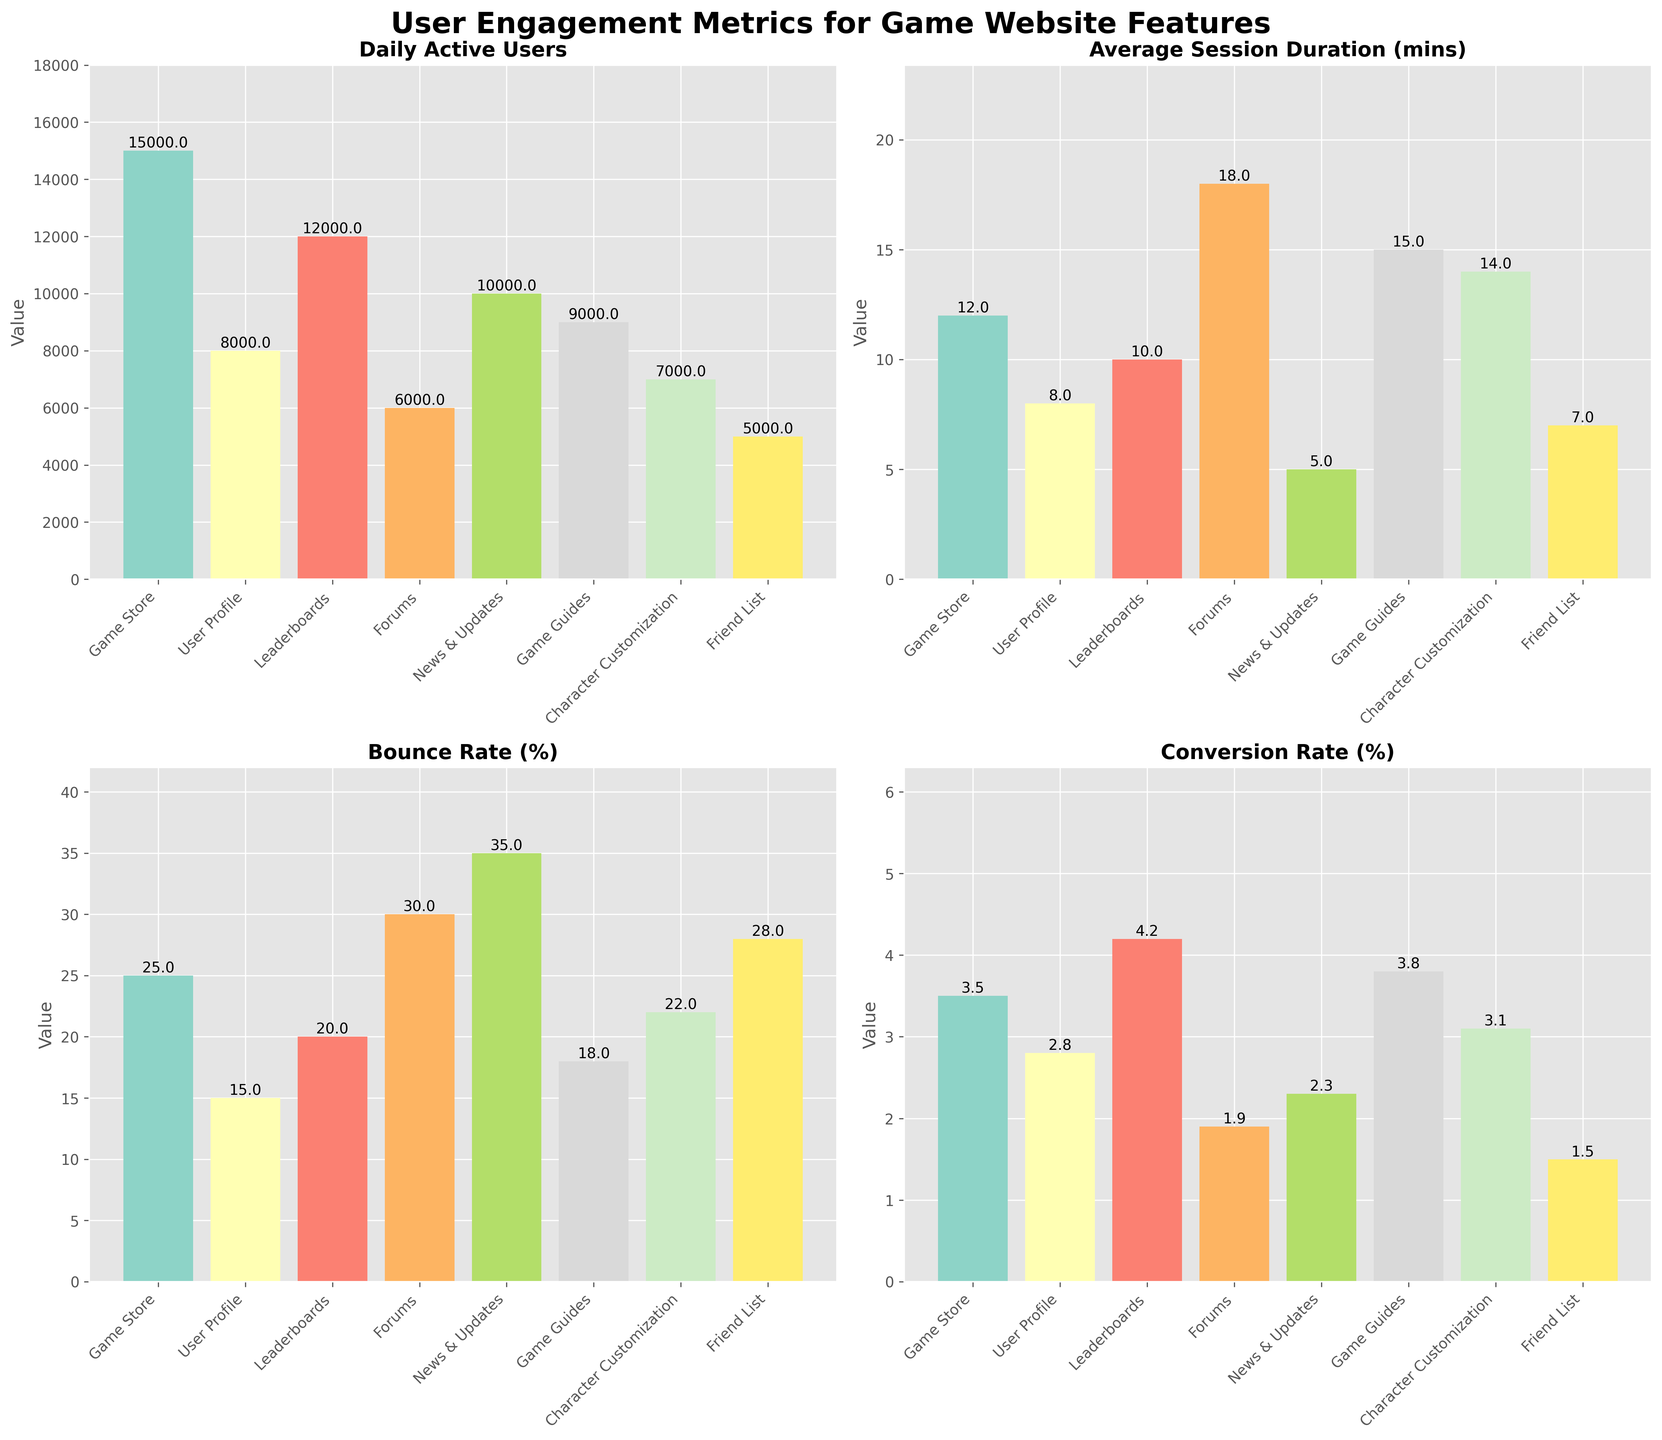what is the total number of daily active users for all features? Add up the Daily Active Users across all features: 15000 + 8000 + 12000 + 6000 + 10000 + 9000 + 7000 + 5000 = 82000
Answer: 82000 which feature has the highest average session duration? Look at the Average Session Duration (mins) subplot and identify the feature with the highest bar. Forums have a value of 18 mins.
Answer: Forums how does the bounce rate of news & updates compare to game store? Compare the heights of the Bounce Rate (%) bars for News & Updates and Game Store. News & Updates has 35% and Game Store has 25%.
Answer: News & Updates has a higher bounce rate what is the difference in conversion rate between leaderboards and friend list? Subtract the Conversion Rate (%) of Friend List from that of Leaderboards: 4.2 - 1.5 = 2.7
Answer: 2.7 which feature has the lowest bounce rate? Identify the shortest bar in the Bounce Rate (%) subplot. User Profile has a value of 15%.
Answer: User Profile if you sum up the average session duration of user profile and character customization, what do you get? Add the Average Session Duration (mins) for User Profile (8 mins) and Character Customization (14 mins): 8 + 14 = 22
Answer: 22 how many features have more than 10000 daily active users? Count the number of bars in the Daily Active Users subplot that are higher than 10000. Game Store, Leaderboards, and News & Updates have more than 10000 daily active users.
Answer: 3 which feature has the highest conversion rate and what is its value? Find the tallest bar in the Conversion Rate (%) subplot. Leaderboards have the highest conversion rate at 4.2%.
Answer: Leaderboards, 4.2 compare the average session duration of game guides and forums. which one is higher, and by how much? Look at the Average Session Duration (mins) of Game Guides (15 mins) and Forums (18 mins), then subtract the smaller value from the larger one: 18 - 15 = 3. Forums have a higher average session duration by 3 mins.
Answer: Forums by 3 which feature has the least daily active users and what does the value represent? Identify the shortest bar in the Daily Active Users subplot. Friend List has the least daily active users at 5000.
Answer: Friend List, 5000 